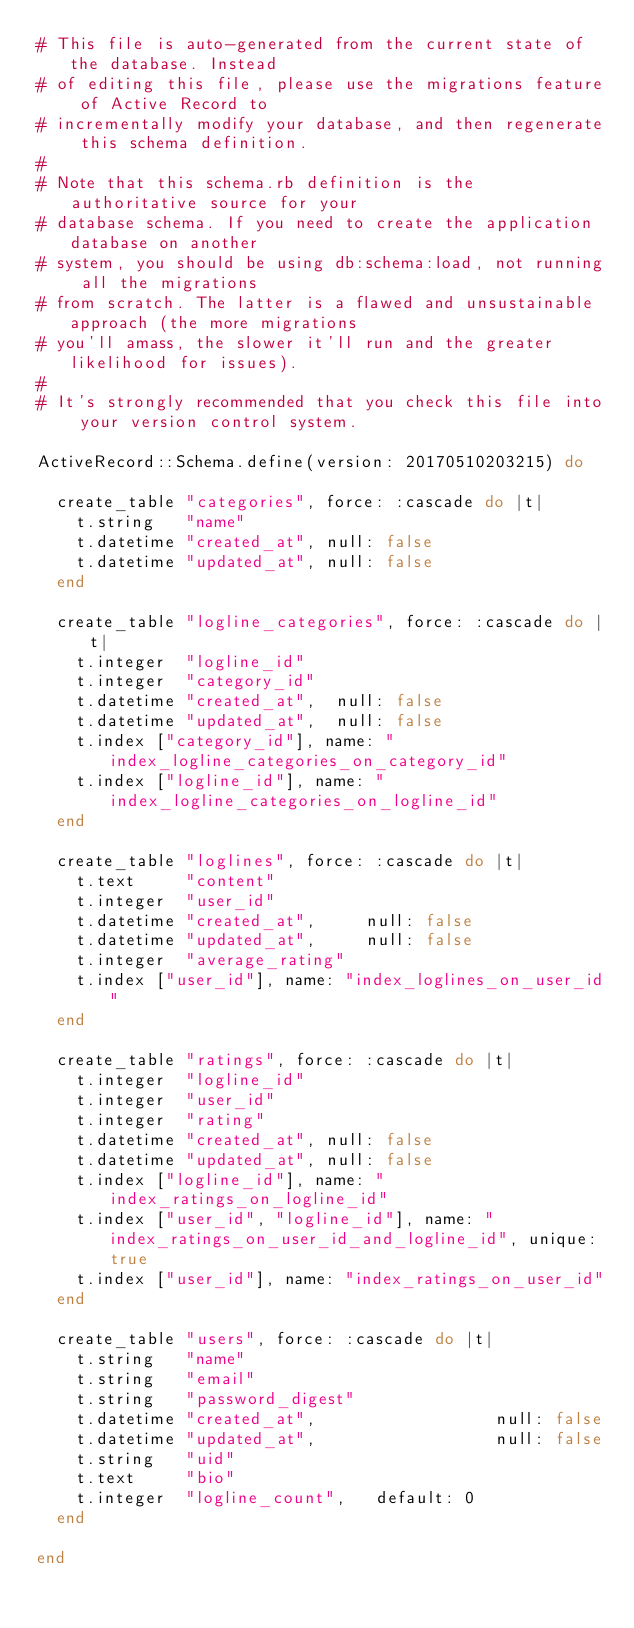Convert code to text. <code><loc_0><loc_0><loc_500><loc_500><_Ruby_># This file is auto-generated from the current state of the database. Instead
# of editing this file, please use the migrations feature of Active Record to
# incrementally modify your database, and then regenerate this schema definition.
#
# Note that this schema.rb definition is the authoritative source for your
# database schema. If you need to create the application database on another
# system, you should be using db:schema:load, not running all the migrations
# from scratch. The latter is a flawed and unsustainable approach (the more migrations
# you'll amass, the slower it'll run and the greater likelihood for issues).
#
# It's strongly recommended that you check this file into your version control system.

ActiveRecord::Schema.define(version: 20170510203215) do

  create_table "categories", force: :cascade do |t|
    t.string   "name"
    t.datetime "created_at", null: false
    t.datetime "updated_at", null: false
  end

  create_table "logline_categories", force: :cascade do |t|
    t.integer  "logline_id"
    t.integer  "category_id"
    t.datetime "created_at",  null: false
    t.datetime "updated_at",  null: false
    t.index ["category_id"], name: "index_logline_categories_on_category_id"
    t.index ["logline_id"], name: "index_logline_categories_on_logline_id"
  end

  create_table "loglines", force: :cascade do |t|
    t.text     "content"
    t.integer  "user_id"
    t.datetime "created_at",     null: false
    t.datetime "updated_at",     null: false
    t.integer  "average_rating"
    t.index ["user_id"], name: "index_loglines_on_user_id"
  end

  create_table "ratings", force: :cascade do |t|
    t.integer  "logline_id"
    t.integer  "user_id"
    t.integer  "rating"
    t.datetime "created_at", null: false
    t.datetime "updated_at", null: false
    t.index ["logline_id"], name: "index_ratings_on_logline_id"
    t.index ["user_id", "logline_id"], name: "index_ratings_on_user_id_and_logline_id", unique: true
    t.index ["user_id"], name: "index_ratings_on_user_id"
  end

  create_table "users", force: :cascade do |t|
    t.string   "name"
    t.string   "email"
    t.string   "password_digest"
    t.datetime "created_at",                  null: false
    t.datetime "updated_at",                  null: false
    t.string   "uid"
    t.text     "bio"
    t.integer  "logline_count",   default: 0
  end

end
</code> 